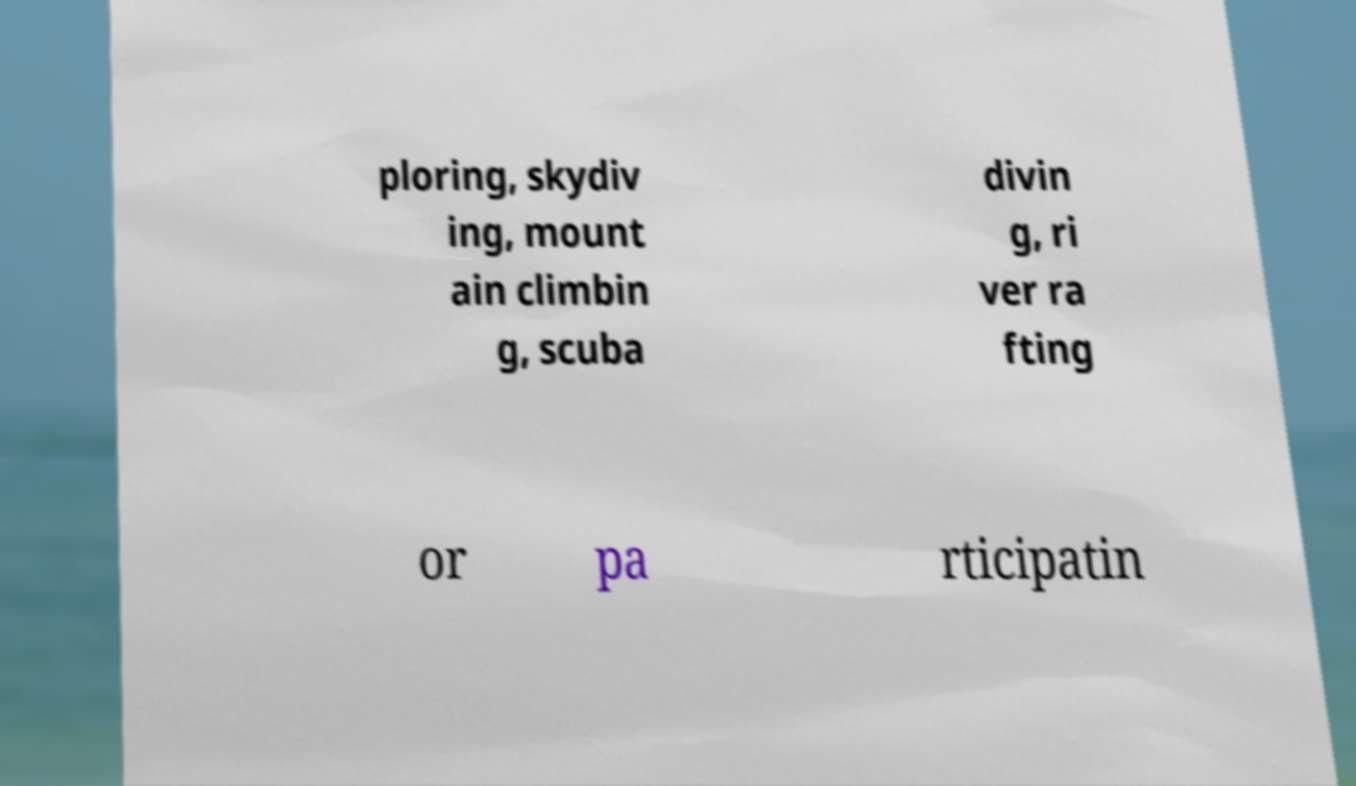Can you read and provide the text displayed in the image?This photo seems to have some interesting text. Can you extract and type it out for me? ploring, skydiv ing, mount ain climbin g, scuba divin g, ri ver ra fting or pa rticipatin 